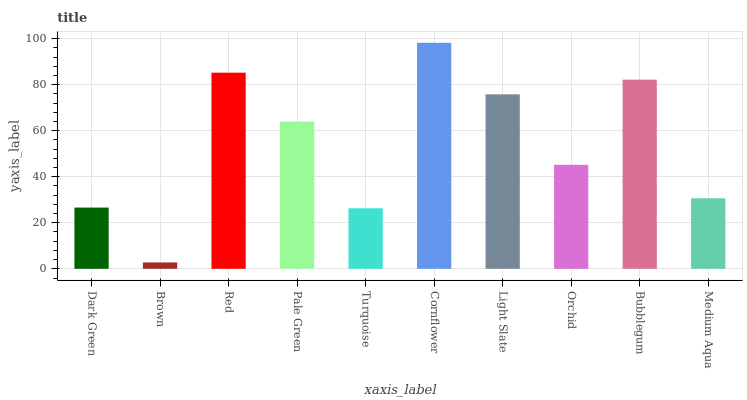Is Red the minimum?
Answer yes or no. No. Is Red the maximum?
Answer yes or no. No. Is Red greater than Brown?
Answer yes or no. Yes. Is Brown less than Red?
Answer yes or no. Yes. Is Brown greater than Red?
Answer yes or no. No. Is Red less than Brown?
Answer yes or no. No. Is Pale Green the high median?
Answer yes or no. Yes. Is Orchid the low median?
Answer yes or no. Yes. Is Bubblegum the high median?
Answer yes or no. No. Is Cornflower the low median?
Answer yes or no. No. 